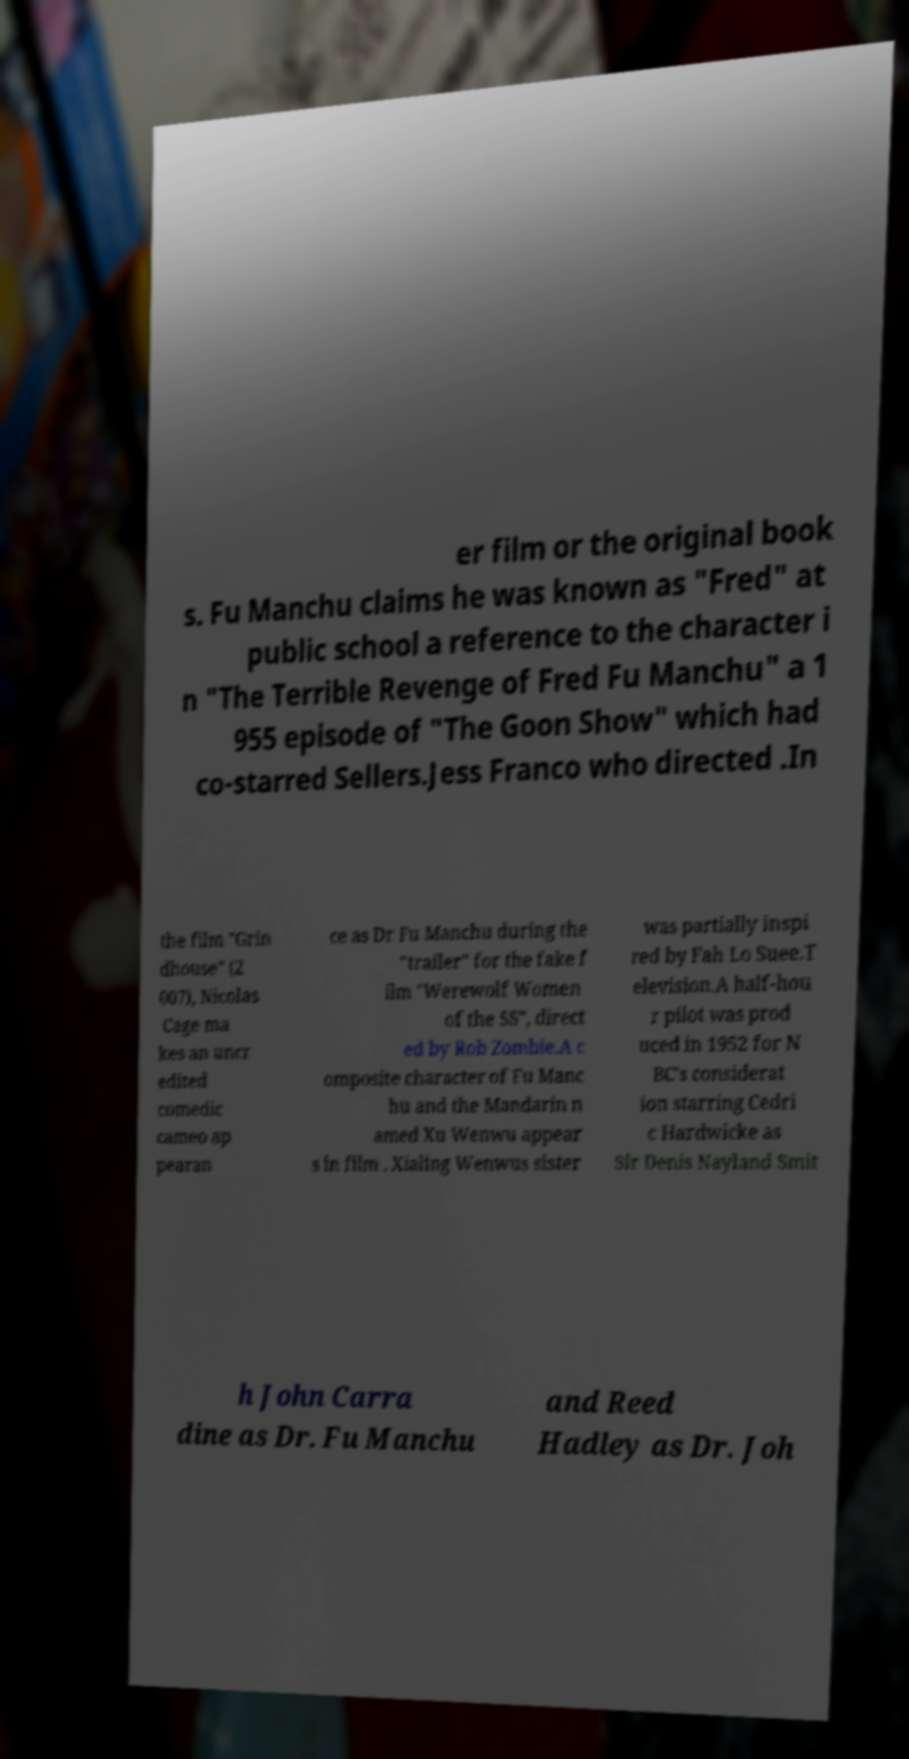Could you assist in decoding the text presented in this image and type it out clearly? er film or the original book s. Fu Manchu claims he was known as "Fred" at public school a reference to the character i n "The Terrible Revenge of Fred Fu Manchu" a 1 955 episode of "The Goon Show" which had co-starred Sellers.Jess Franco who directed .In the film "Grin dhouse" (2 007), Nicolas Cage ma kes an uncr edited comedic cameo ap pearan ce as Dr Fu Manchu during the "trailer" for the fake f ilm "Werewolf Women of the SS", direct ed by Rob Zombie.A c omposite character of Fu Manc hu and the Mandarin n amed Xu Wenwu appear s in film . Xialing Wenwus sister was partially inspi red by Fah Lo Suee.T elevision.A half-hou r pilot was prod uced in 1952 for N BC's considerat ion starring Cedri c Hardwicke as Sir Denis Nayland Smit h John Carra dine as Dr. Fu Manchu and Reed Hadley as Dr. Joh 